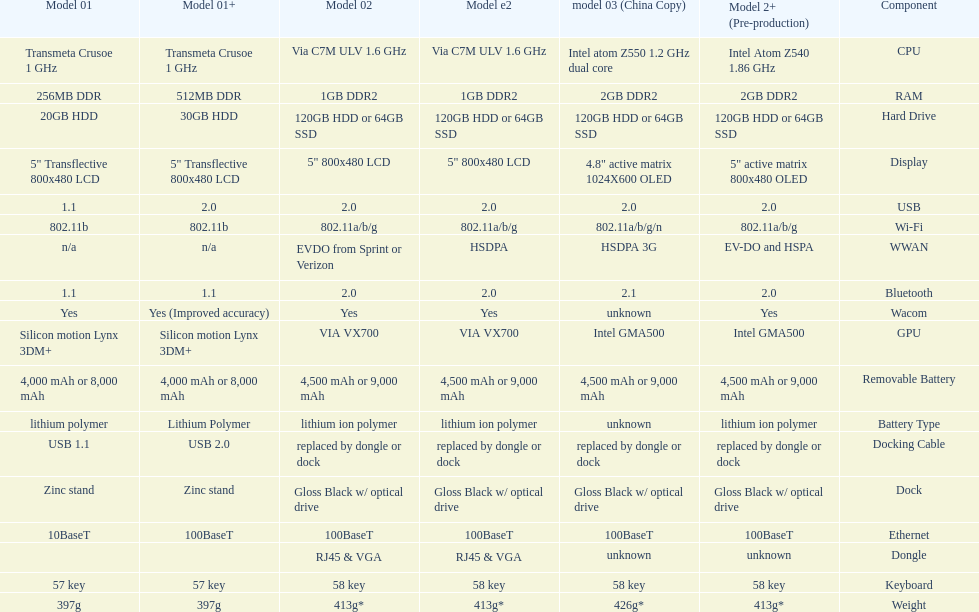I'm looking to parse the entire table for insights. Could you assist me with that? {'header': ['Model 01', 'Model 01+', 'Model 02', 'Model e2', 'model 03 (China Copy)', 'Model 2+ (Pre-production)', 'Component'], 'rows': [['Transmeta Crusoe 1\xa0GHz', 'Transmeta Crusoe 1\xa0GHz', 'Via C7M ULV 1.6\xa0GHz', 'Via C7M ULV 1.6\xa0GHz', 'Intel atom Z550 1.2\xa0GHz dual core', 'Intel Atom Z540 1.86\xa0GHz', 'CPU'], ['256MB DDR', '512MB DDR', '1GB DDR2', '1GB DDR2', '2GB DDR2', '2GB DDR2', 'RAM'], ['20GB HDD', '30GB HDD', '120GB HDD or 64GB SSD', '120GB HDD or 64GB SSD', '120GB HDD or 64GB SSD', '120GB HDD or 64GB SSD', 'Hard Drive'], ['5" Transflective 800x480 LCD', '5" Transflective 800x480 LCD', '5" 800x480 LCD', '5" 800x480 LCD', '4.8" active matrix 1024X600 OLED', '5" active matrix 800x480 OLED', 'Display'], ['1.1', '2.0', '2.0', '2.0', '2.0', '2.0', 'USB'], ['802.11b', '802.11b', '802.11a/b/g', '802.11a/b/g', '802.11a/b/g/n', '802.11a/b/g', 'Wi-Fi'], ['n/a', 'n/a', 'EVDO from Sprint or Verizon', 'HSDPA', 'HSDPA 3G', 'EV-DO and HSPA', 'WWAN'], ['1.1', '1.1', '2.0', '2.0', '2.1', '2.0', 'Bluetooth'], ['Yes', 'Yes (Improved accuracy)', 'Yes', 'Yes', 'unknown', 'Yes', 'Wacom'], ['Silicon motion Lynx 3DM+', 'Silicon motion Lynx 3DM+', 'VIA VX700', 'VIA VX700', 'Intel GMA500', 'Intel GMA500', 'GPU'], ['4,000 mAh or 8,000 mAh', '4,000 mAh or 8,000 mAh', '4,500 mAh or 9,000 mAh', '4,500 mAh or 9,000 mAh', '4,500 mAh or 9,000 mAh', '4,500 mAh or 9,000 mAh', 'Removable Battery'], ['lithium polymer', 'Lithium Polymer', 'lithium ion polymer', 'lithium ion polymer', 'unknown', 'lithium ion polymer', 'Battery Type'], ['USB 1.1', 'USB 2.0', 'replaced by dongle or dock', 'replaced by dongle or dock', 'replaced by dongle or dock', 'replaced by dongle or dock', 'Docking Cable'], ['Zinc stand', 'Zinc stand', 'Gloss Black w/ optical drive', 'Gloss Black w/ optical drive', 'Gloss Black w/ optical drive', 'Gloss Black w/ optical drive', 'Dock'], ['10BaseT', '100BaseT', '100BaseT', '100BaseT', '100BaseT', '100BaseT', 'Ethernet'], ['', '', 'RJ45 & VGA', 'RJ45 & VGA', 'unknown', 'unknown', 'Dongle'], ['57 key', '57 key', '58 key', '58 key', '58 key', '58 key', 'Keyboard'], ['397g', '397g', '413g*', '413g*', '426g*', '413g*', 'Weight']]} The model 2 and the model 2e have what type of cpu? Via C7M ULV 1.6 GHz. 